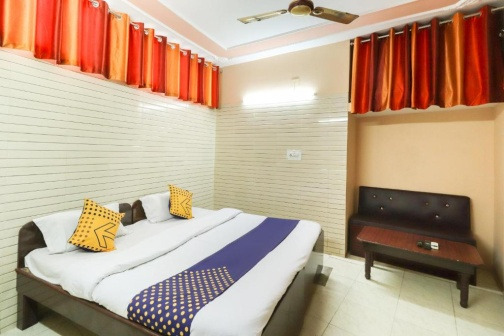Describe the following image. The image features a well-arranged bedroom scene, which is predominantly occupied by a large double bed with a striking blue comforter adorned with white polka dots. Adding a vibrant touch are two yellow throw pillows with geometric patterns. Alongside the right wall, there's a simplistic dark wood sofa adding to the functional elements of the room.

The walls of the room are finished with white tiles, while a textural beige wall adds contrast directly behind the bed. A red curtain, contrasting vividly against the otherwise neutral palette, hangs over a window, adding a layer of privacy and vibrant color. The ceiling fan above enables air circulation, appropriate for maintaining comfort in what appears to be a warm setting.

This calm and practical bedroom setup, with its balanced color scheme and thoughtful furnishings, suggests a space designed for relaxation and simplicity. 